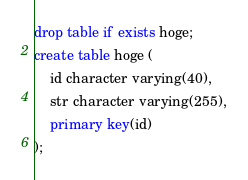Convert code to text. <code><loc_0><loc_0><loc_500><loc_500><_SQL_>drop table if exists hoge;
create table hoge (
    id character varying(40),
    str character varying(255),
    primary key(id)
);
</code> 